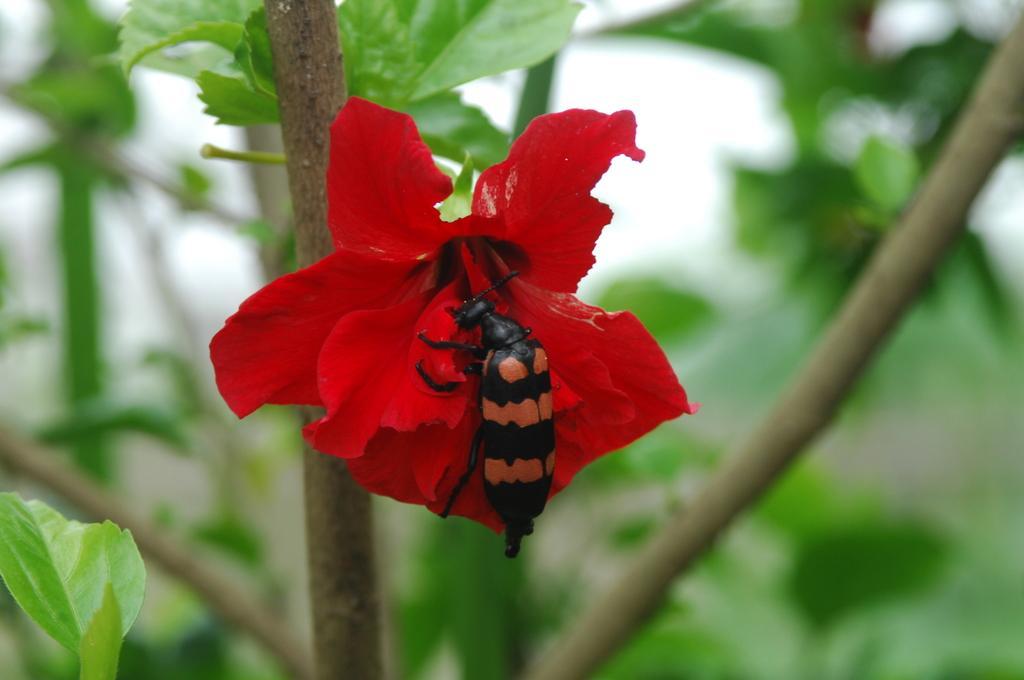In one or two sentences, can you explain what this image depicts? In this image there is an insect on the red color hibiscus flower , and there is blur background. 